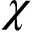<formula> <loc_0><loc_0><loc_500><loc_500>\chi</formula> 